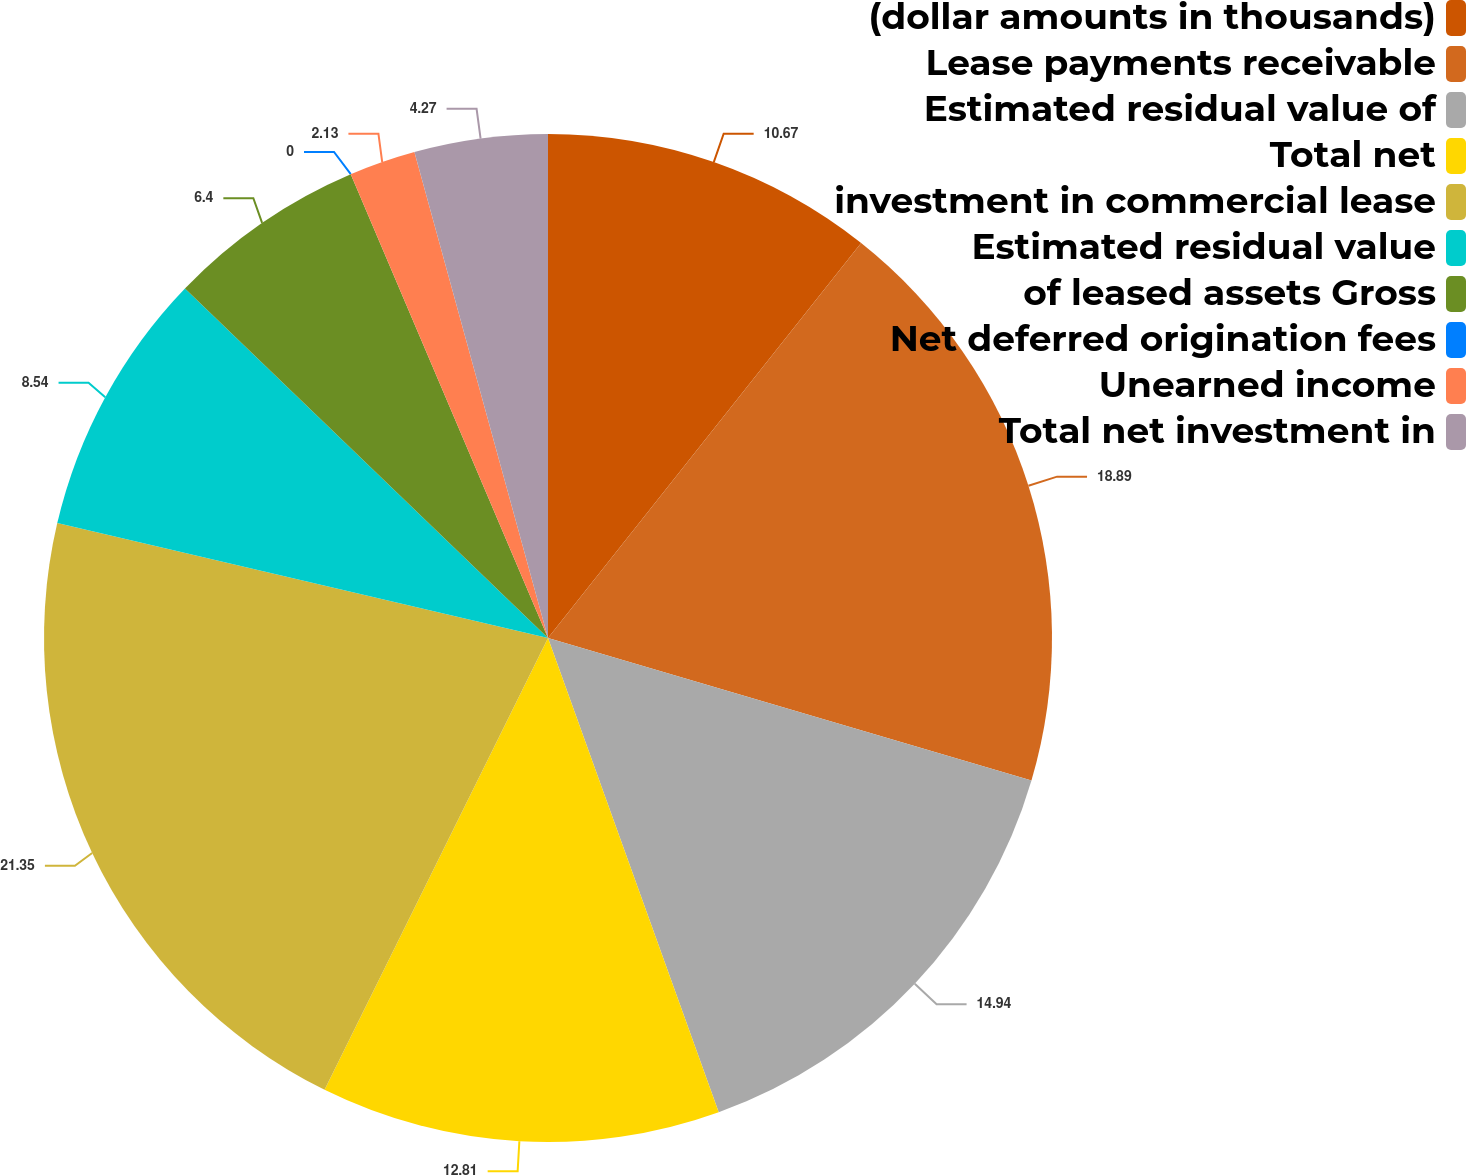Convert chart to OTSL. <chart><loc_0><loc_0><loc_500><loc_500><pie_chart><fcel>(dollar amounts in thousands)<fcel>Lease payments receivable<fcel>Estimated residual value of<fcel>Total net<fcel>investment in commercial lease<fcel>Estimated residual value<fcel>of leased assets Gross<fcel>Net deferred origination fees<fcel>Unearned income<fcel>Total net investment in<nl><fcel>10.67%<fcel>18.89%<fcel>14.94%<fcel>12.81%<fcel>21.35%<fcel>8.54%<fcel>6.4%<fcel>0.0%<fcel>2.13%<fcel>4.27%<nl></chart> 